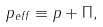<formula> <loc_0><loc_0><loc_500><loc_500>p _ { e f f } \equiv p + \Pi ,</formula> 